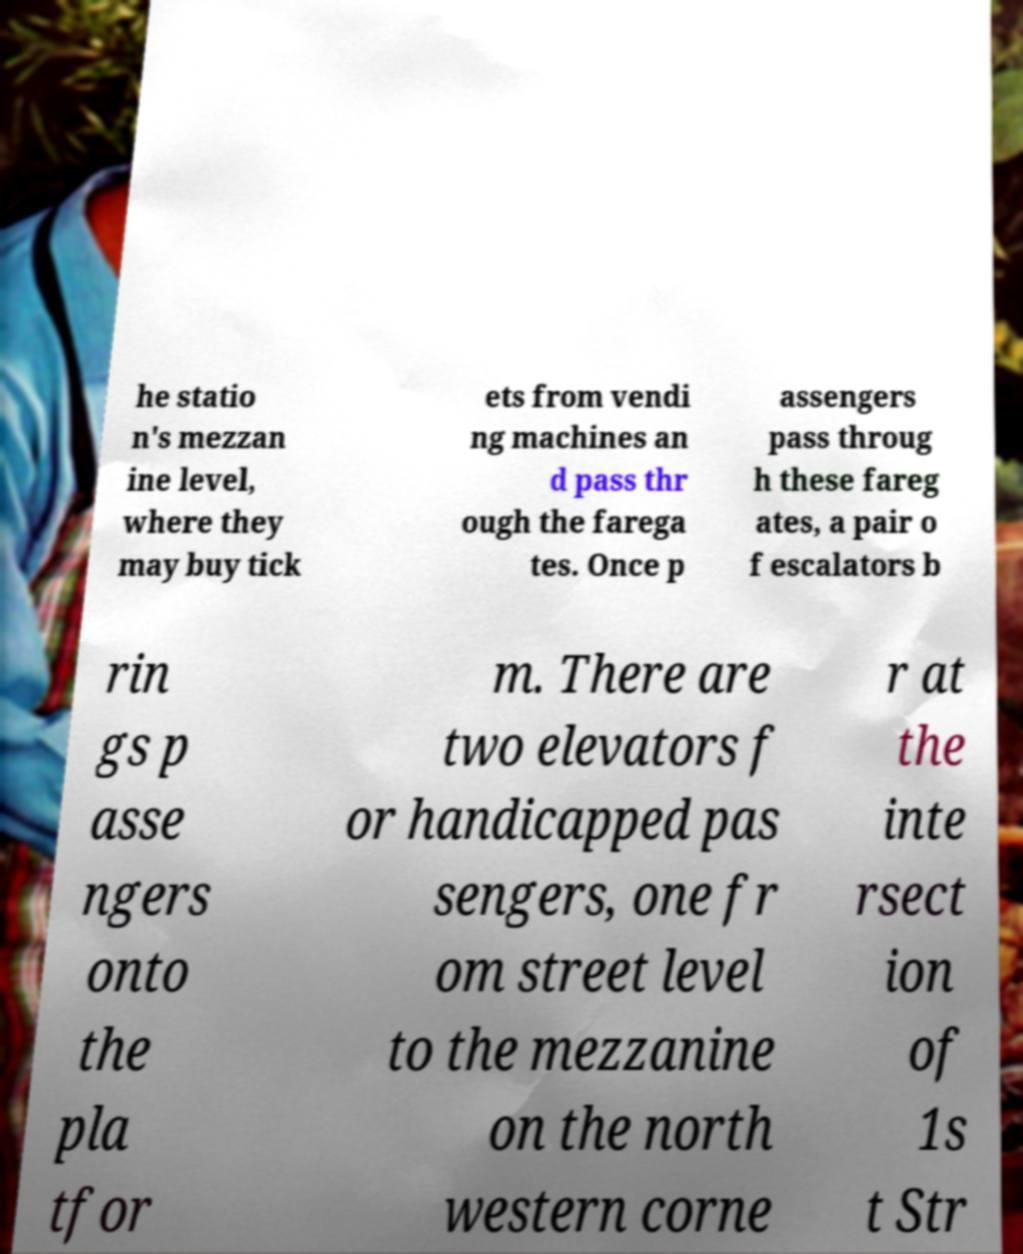There's text embedded in this image that I need extracted. Can you transcribe it verbatim? he statio n's mezzan ine level, where they may buy tick ets from vendi ng machines an d pass thr ough the farega tes. Once p assengers pass throug h these fareg ates, a pair o f escalators b rin gs p asse ngers onto the pla tfor m. There are two elevators f or handicapped pas sengers, one fr om street level to the mezzanine on the north western corne r at the inte rsect ion of 1s t Str 